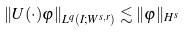<formula> <loc_0><loc_0><loc_500><loc_500>\left \| U ( \cdot ) \varphi \right \| _ { L ^ { q } ( I ; W ^ { s , r } ) } \lesssim \| \varphi \| _ { H ^ { s } }</formula> 